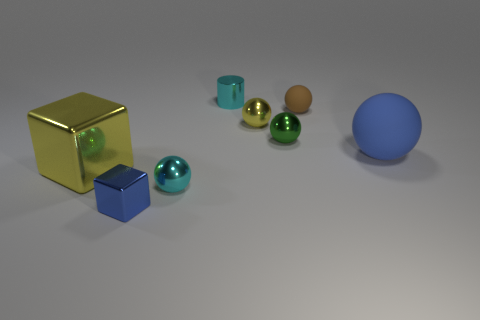Subtract all cyan spheres. How many spheres are left? 4 Add 1 tiny brown things. How many objects exist? 9 Subtract all cyan spheres. How many spheres are left? 4 Subtract all spheres. How many objects are left? 3 Add 4 tiny blue matte cylinders. How many tiny blue matte cylinders exist? 4 Subtract 0 gray cylinders. How many objects are left? 8 Subtract 1 balls. How many balls are left? 4 Subtract all red blocks. Subtract all blue balls. How many blocks are left? 2 Subtract all blue blocks. How many red balls are left? 0 Subtract all tiny metal cubes. Subtract all tiny cyan metal balls. How many objects are left? 6 